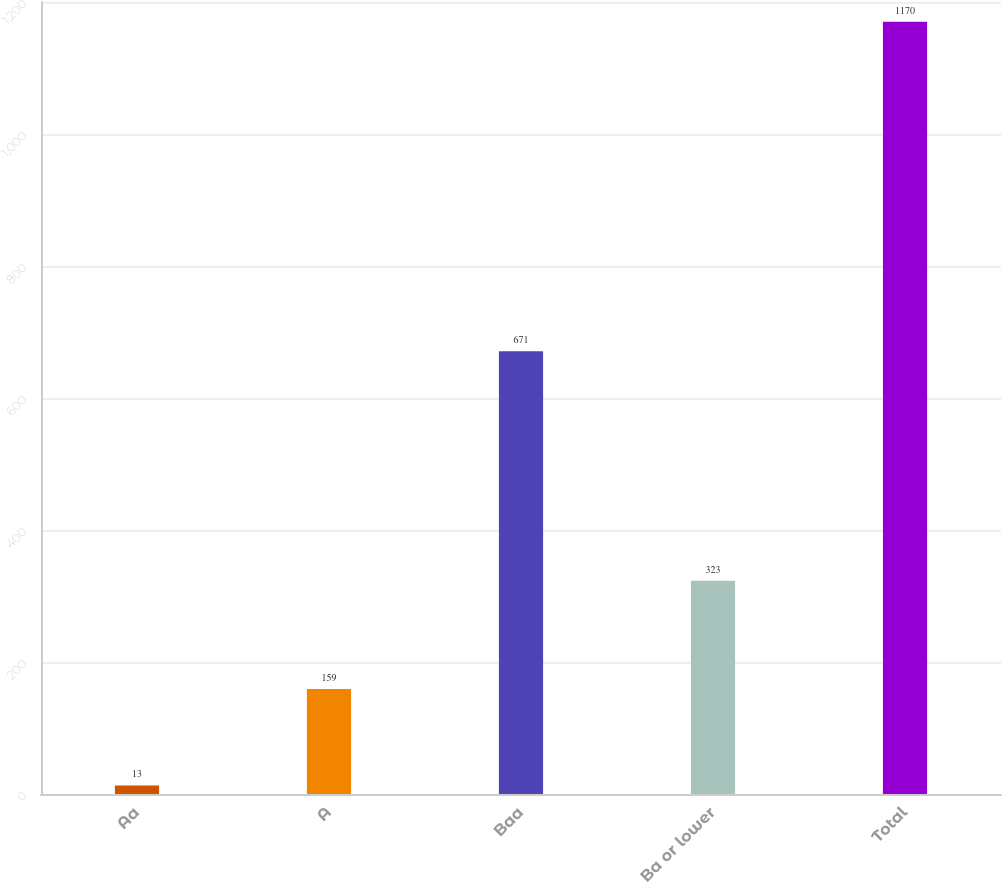<chart> <loc_0><loc_0><loc_500><loc_500><bar_chart><fcel>Aa<fcel>A<fcel>Baa<fcel>Ba or lower<fcel>Total<nl><fcel>13<fcel>159<fcel>671<fcel>323<fcel>1170<nl></chart> 